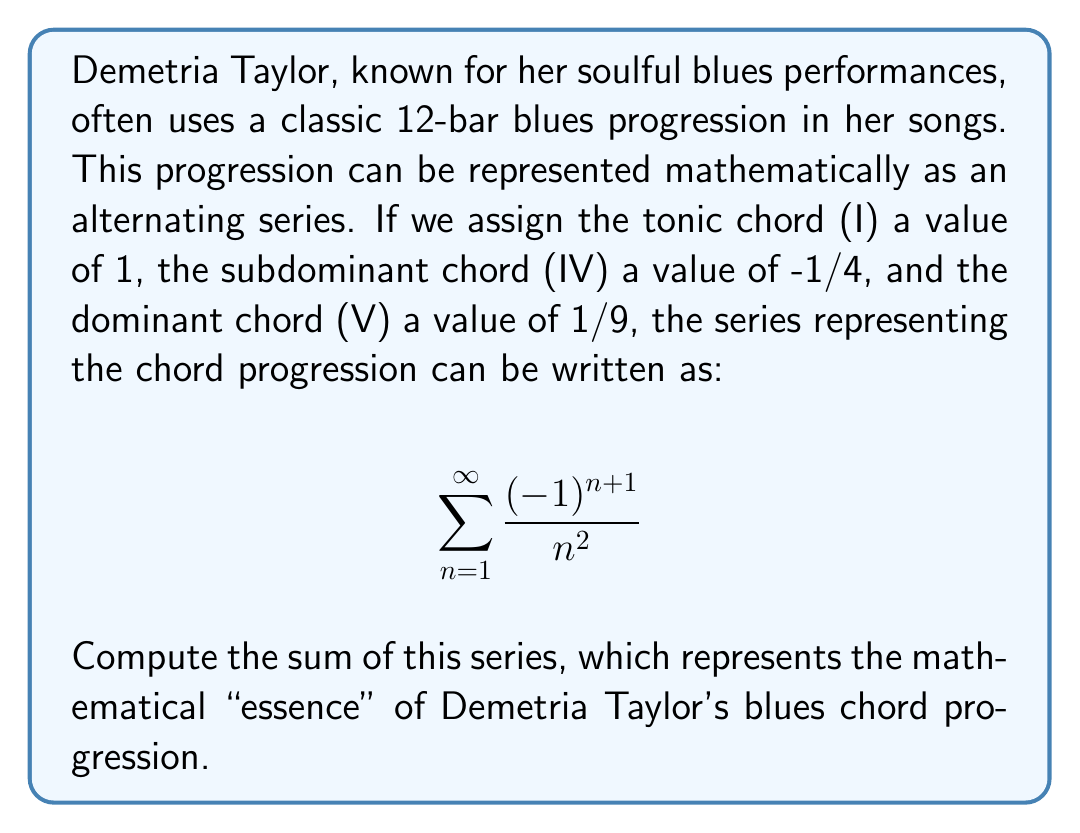Can you solve this math problem? To solve this problem, we need to recognize that this is a well-known series called the alternating Dirichlet eta function for s=2. The sum of this series is related to the Riemann zeta function ζ(s) by the formula:

$$\eta(s) = (1-2^{1-s})\zeta(s)$$

For s=2, we have:

1) First, recall that ζ(2) = π²/6. This is a famous result known as the Basel problem.

2) Now, let's apply the formula:

   $$\eta(2) = (1-2^{1-2})\zeta(2) = (1-\frac{1}{2})\frac{\pi^2}{6} = \frac{\pi^2}{12}$$

3) Therefore, the sum of our series is:

   $$\sum_{n=1}^{\infty} \frac{(-1)^{n+1}}{n^2} = \frac{\pi^2}{12}$$

This result represents the mathematical convergence of the blues chord progression, mirroring how Demetria Taylor's music brings together different chord elements into a harmonious whole.
Answer: $$\frac{\pi^2}{12}$$ 